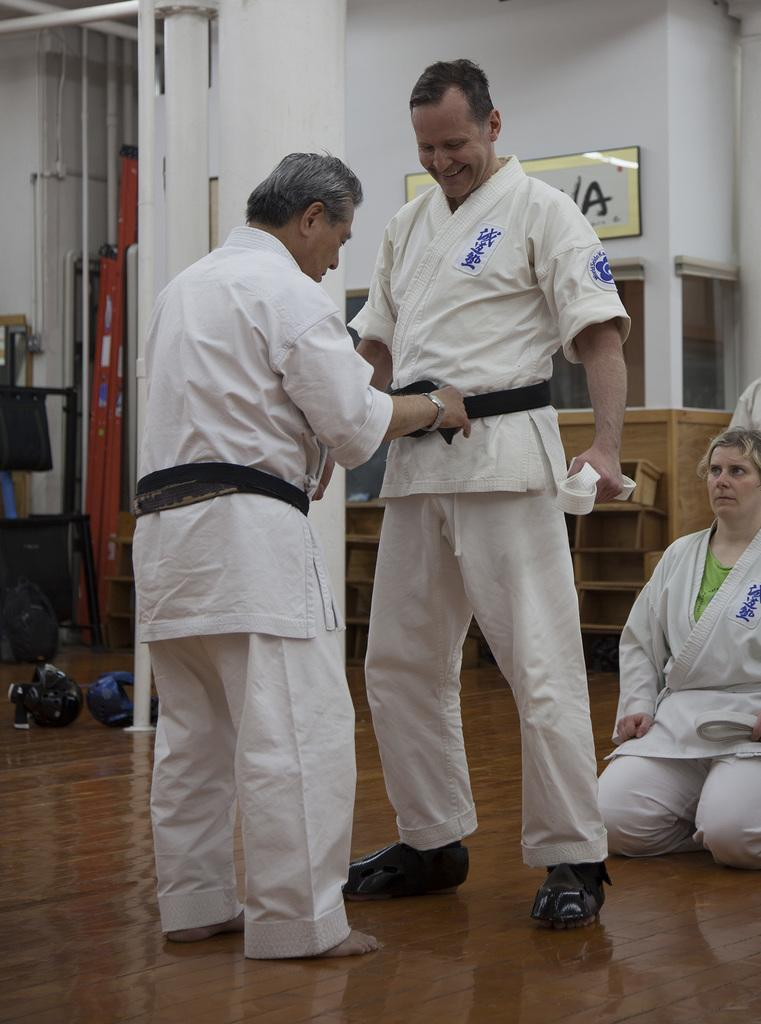<image>
Describe the image concisely. A man wearing a black belt puts a black belt on another man who is standing in front of a sign with the letter A on it. 